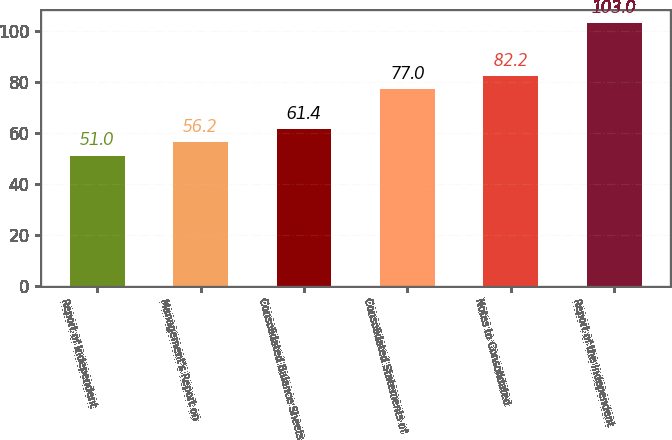Convert chart to OTSL. <chart><loc_0><loc_0><loc_500><loc_500><bar_chart><fcel>Report of Independent<fcel>Management's Report on<fcel>Consolidated Balance Sheets<fcel>Consolidated Statements of<fcel>Notes to Consolidated<fcel>Report of the Independent<nl><fcel>51<fcel>56.2<fcel>61.4<fcel>77<fcel>82.2<fcel>103<nl></chart> 